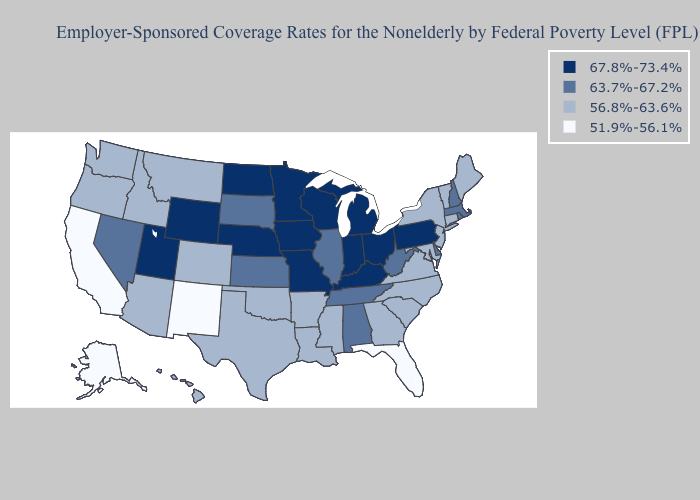What is the value of Colorado?
Give a very brief answer. 56.8%-63.6%. Does New Mexico have the lowest value in the USA?
Answer briefly. Yes. What is the highest value in the USA?
Be succinct. 67.8%-73.4%. Does the map have missing data?
Concise answer only. No. Name the states that have a value in the range 56.8%-63.6%?
Short answer required. Arizona, Arkansas, Colorado, Connecticut, Georgia, Hawaii, Idaho, Louisiana, Maine, Maryland, Mississippi, Montana, New Jersey, New York, North Carolina, Oklahoma, Oregon, South Carolina, Texas, Vermont, Virginia, Washington. Does Kentucky have the highest value in the South?
Keep it brief. Yes. Does North Dakota have a lower value than Minnesota?
Concise answer only. No. Name the states that have a value in the range 51.9%-56.1%?
Keep it brief. Alaska, California, Florida, New Mexico. Among the states that border Idaho , does Utah have the highest value?
Give a very brief answer. Yes. Name the states that have a value in the range 56.8%-63.6%?
Answer briefly. Arizona, Arkansas, Colorado, Connecticut, Georgia, Hawaii, Idaho, Louisiana, Maine, Maryland, Mississippi, Montana, New Jersey, New York, North Carolina, Oklahoma, Oregon, South Carolina, Texas, Vermont, Virginia, Washington. Among the states that border New York , which have the highest value?
Write a very short answer. Pennsylvania. Which states have the lowest value in the USA?
Keep it brief. Alaska, California, Florida, New Mexico. Does the first symbol in the legend represent the smallest category?
Answer briefly. No. Name the states that have a value in the range 51.9%-56.1%?
Concise answer only. Alaska, California, Florida, New Mexico. What is the value of Alaska?
Write a very short answer. 51.9%-56.1%. 